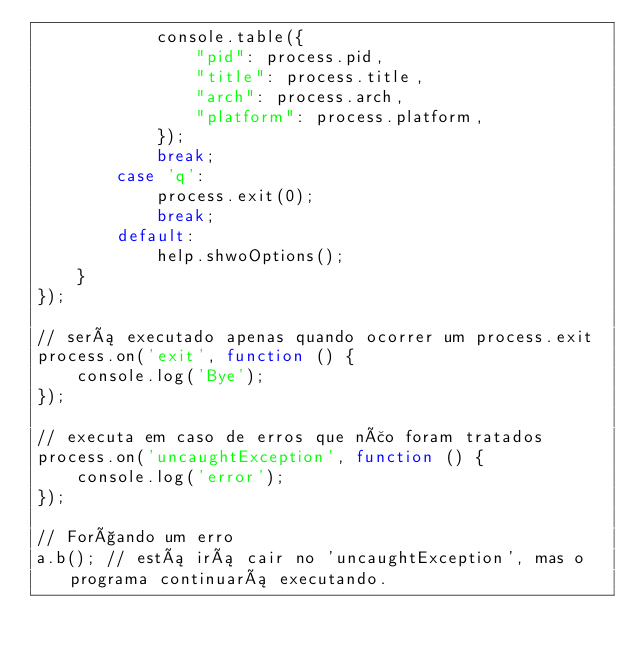Convert code to text. <code><loc_0><loc_0><loc_500><loc_500><_JavaScript_>            console.table({ 
                "pid": process.pid, 
                "title": process.title, 
                "arch": process.arch, 
                "platform": process.platform,
            });
            break;
        case 'q':
            process.exit(0);
            break;
        default:
            help.shwoOptions();
    }
});

// será executado apenas quando ocorrer um process.exit
process.on('exit', function () {
    console.log('Bye');
});

// executa em caso de erros que não foram tratados
process.on('uncaughtException', function () {
    console.log('error');
});

// Forçando um erro
a.b(); // está irá cair no 'uncaughtException', mas o programa continuará executando.</code> 